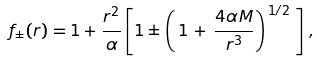<formula> <loc_0><loc_0><loc_500><loc_500>f _ { \pm } ( r ) = 1 + \frac { r ^ { 2 } } { \alpha } \left [ 1 \pm \left ( \, 1 \, + \, \frac { 4 \alpha M } { r ^ { 3 } } \right ) ^ { \, 1 / 2 \, } \, \right ] \, ,</formula> 